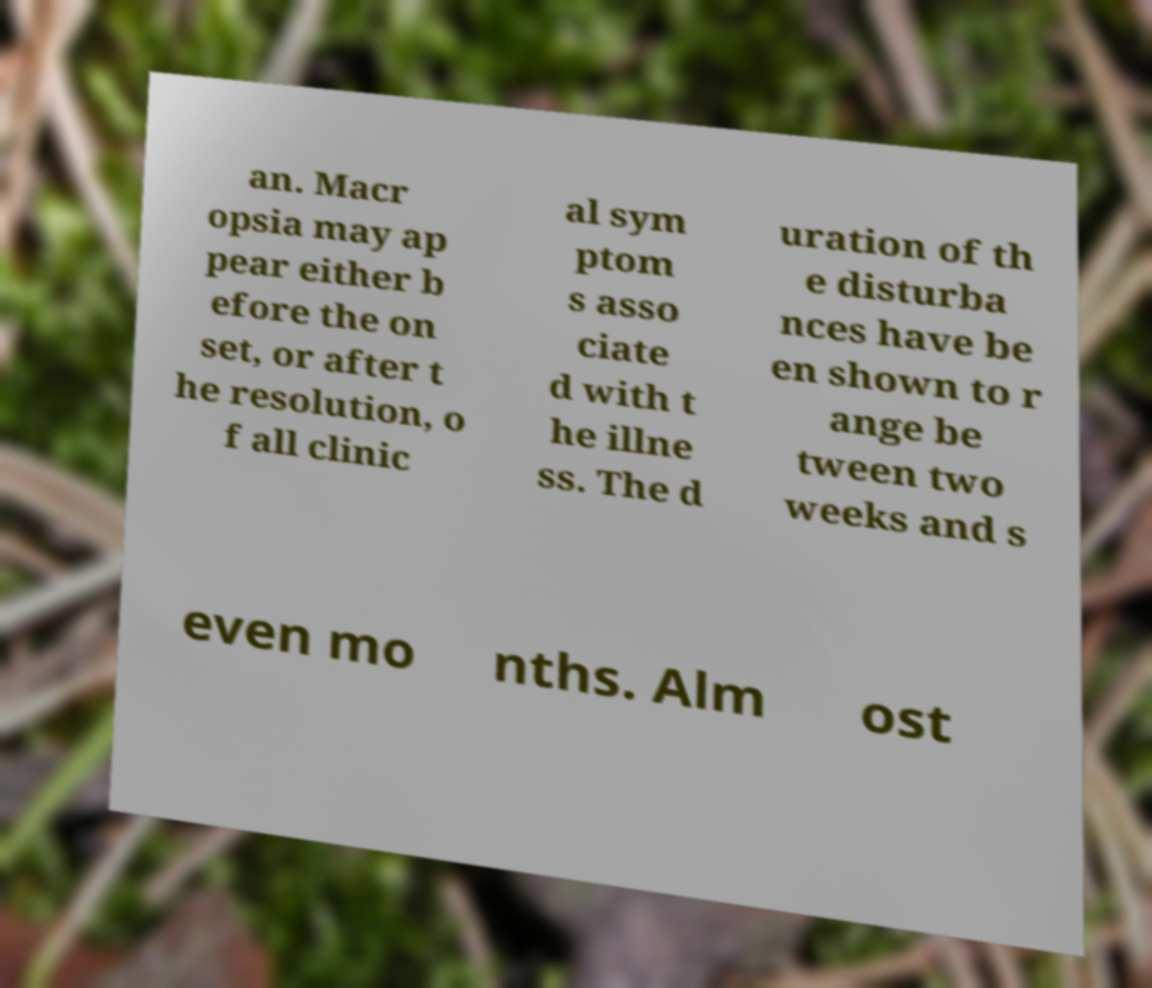Please identify and transcribe the text found in this image. an. Macr opsia may ap pear either b efore the on set, or after t he resolution, o f all clinic al sym ptom s asso ciate d with t he illne ss. The d uration of th e disturba nces have be en shown to r ange be tween two weeks and s even mo nths. Alm ost 